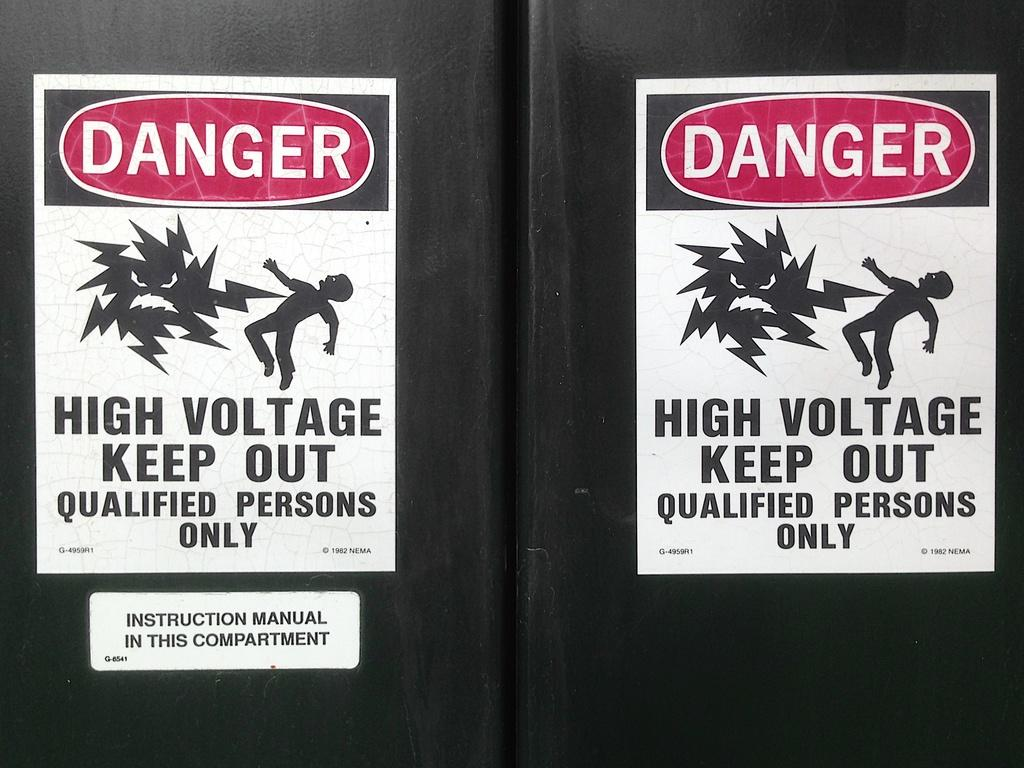What objects in the image have text on them? The sign boards in the image have text on them. Can you describe the appearance of the sign boards? The sign boards are visible in the image. What else can be seen in the image besides the sign boards? There is a curtain in the image. How many cows are standing behind the curtain in the image? There are no cows present in the image. Can you tell me why the shelf is crying in the image? There is no shelf in the image, and objects do not have the ability to cry. 